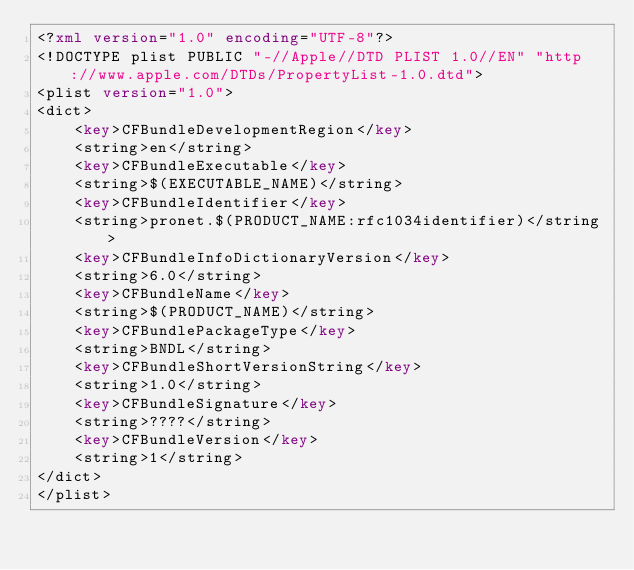Convert code to text. <code><loc_0><loc_0><loc_500><loc_500><_XML_><?xml version="1.0" encoding="UTF-8"?>
<!DOCTYPE plist PUBLIC "-//Apple//DTD PLIST 1.0//EN" "http://www.apple.com/DTDs/PropertyList-1.0.dtd">
<plist version="1.0">
<dict>
	<key>CFBundleDevelopmentRegion</key>
	<string>en</string>
	<key>CFBundleExecutable</key>
	<string>$(EXECUTABLE_NAME)</string>
	<key>CFBundleIdentifier</key>
	<string>pronet.$(PRODUCT_NAME:rfc1034identifier)</string>
	<key>CFBundleInfoDictionaryVersion</key>
	<string>6.0</string>
	<key>CFBundleName</key>
	<string>$(PRODUCT_NAME)</string>
	<key>CFBundlePackageType</key>
	<string>BNDL</string>
	<key>CFBundleShortVersionString</key>
	<string>1.0</string>
	<key>CFBundleSignature</key>
	<string>????</string>
	<key>CFBundleVersion</key>
	<string>1</string>
</dict>
</plist>
</code> 